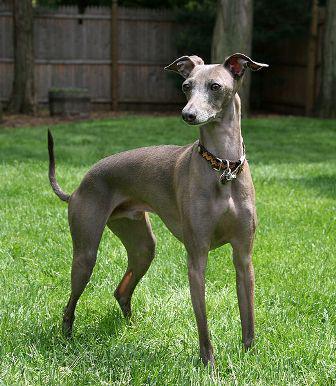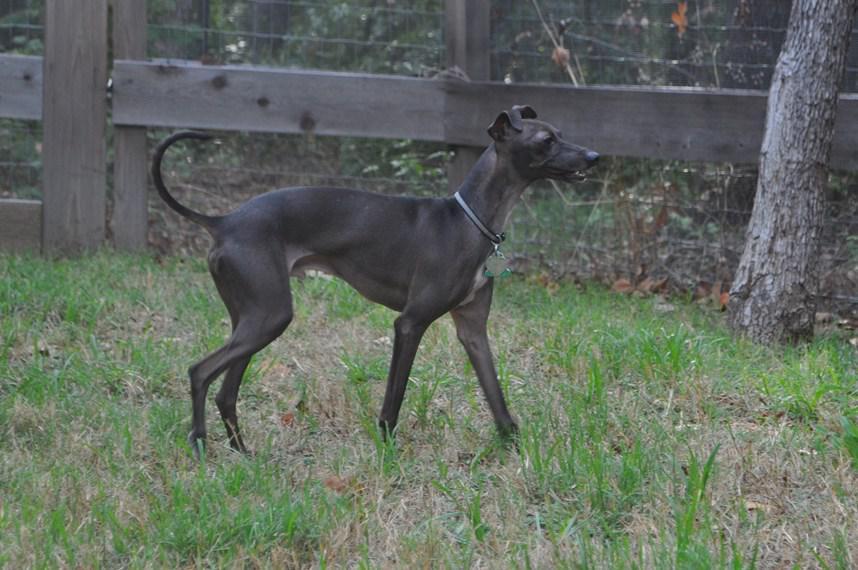The first image is the image on the left, the second image is the image on the right. For the images displayed, is the sentence "Left image shows a dog standing on green grass." factually correct? Answer yes or no. Yes. The first image is the image on the left, the second image is the image on the right. Examine the images to the left and right. Is the description "the dog in the image on the left is standing on grass" accurate? Answer yes or no. Yes. 